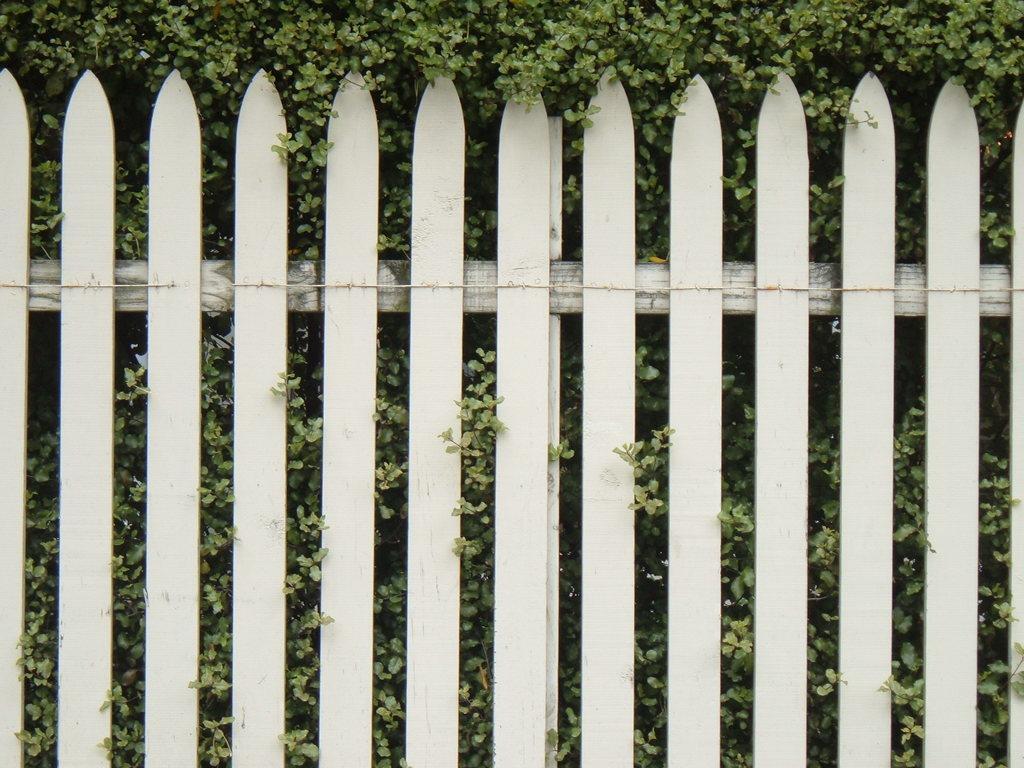Can you describe this image briefly? In this picture I can see there is a fence and there are plants behind the fence. 